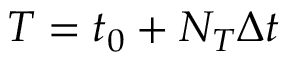<formula> <loc_0><loc_0><loc_500><loc_500>T = t _ { 0 } + N _ { T } \Delta t</formula> 